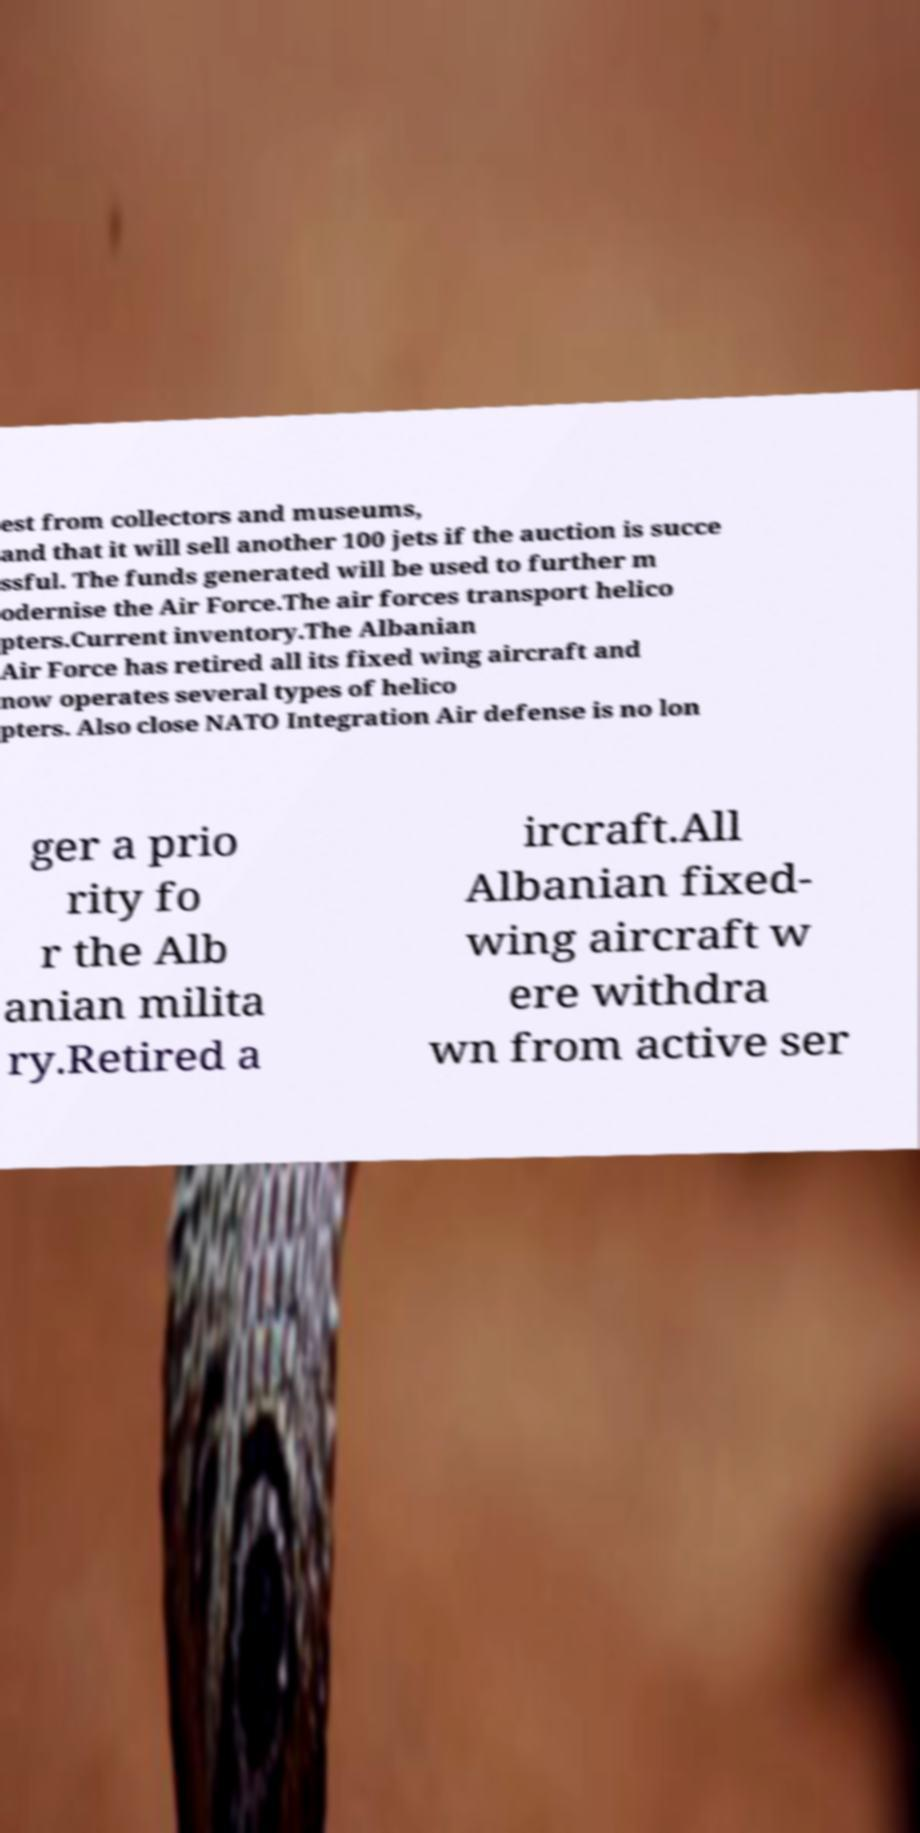What messages or text are displayed in this image? I need them in a readable, typed format. est from collectors and museums, and that it will sell another 100 jets if the auction is succe ssful. The funds generated will be used to further m odernise the Air Force.The air forces transport helico pters.Current inventory.The Albanian Air Force has retired all its fixed wing aircraft and now operates several types of helico pters. Also close NATO Integration Air defense is no lon ger a prio rity fo r the Alb anian milita ry.Retired a ircraft.All Albanian fixed- wing aircraft w ere withdra wn from active ser 